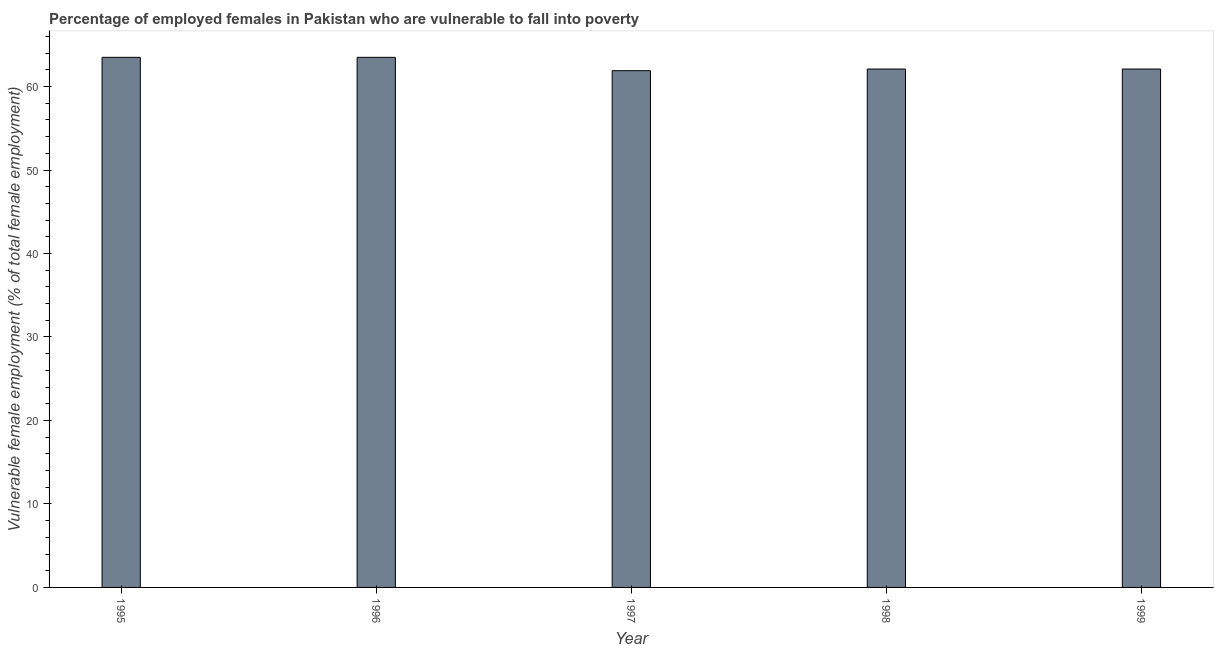Does the graph contain any zero values?
Provide a succinct answer. No. Does the graph contain grids?
Offer a terse response. No. What is the title of the graph?
Your response must be concise. Percentage of employed females in Pakistan who are vulnerable to fall into poverty. What is the label or title of the X-axis?
Provide a succinct answer. Year. What is the label or title of the Y-axis?
Ensure brevity in your answer.  Vulnerable female employment (% of total female employment). What is the percentage of employed females who are vulnerable to fall into poverty in 1999?
Your answer should be very brief. 62.1. Across all years, what is the maximum percentage of employed females who are vulnerable to fall into poverty?
Provide a short and direct response. 63.5. Across all years, what is the minimum percentage of employed females who are vulnerable to fall into poverty?
Provide a short and direct response. 61.9. What is the sum of the percentage of employed females who are vulnerable to fall into poverty?
Provide a short and direct response. 313.1. What is the difference between the percentage of employed females who are vulnerable to fall into poverty in 1995 and 1998?
Provide a succinct answer. 1.4. What is the average percentage of employed females who are vulnerable to fall into poverty per year?
Provide a short and direct response. 62.62. What is the median percentage of employed females who are vulnerable to fall into poverty?
Keep it short and to the point. 62.1. Is the percentage of employed females who are vulnerable to fall into poverty in 1996 less than that in 1997?
Offer a very short reply. No. What is the difference between the highest and the lowest percentage of employed females who are vulnerable to fall into poverty?
Ensure brevity in your answer.  1.6. How many bars are there?
Ensure brevity in your answer.  5. How many years are there in the graph?
Your answer should be compact. 5. What is the difference between two consecutive major ticks on the Y-axis?
Ensure brevity in your answer.  10. Are the values on the major ticks of Y-axis written in scientific E-notation?
Your response must be concise. No. What is the Vulnerable female employment (% of total female employment) in 1995?
Offer a very short reply. 63.5. What is the Vulnerable female employment (% of total female employment) of 1996?
Offer a very short reply. 63.5. What is the Vulnerable female employment (% of total female employment) in 1997?
Provide a short and direct response. 61.9. What is the Vulnerable female employment (% of total female employment) in 1998?
Offer a very short reply. 62.1. What is the Vulnerable female employment (% of total female employment) of 1999?
Give a very brief answer. 62.1. What is the difference between the Vulnerable female employment (% of total female employment) in 1995 and 1998?
Your response must be concise. 1.4. What is the difference between the Vulnerable female employment (% of total female employment) in 1996 and 1997?
Your answer should be compact. 1.6. What is the difference between the Vulnerable female employment (% of total female employment) in 1996 and 1998?
Offer a terse response. 1.4. What is the ratio of the Vulnerable female employment (% of total female employment) in 1995 to that in 1996?
Provide a succinct answer. 1. What is the ratio of the Vulnerable female employment (% of total female employment) in 1995 to that in 1999?
Provide a succinct answer. 1.02. What is the ratio of the Vulnerable female employment (% of total female employment) in 1996 to that in 1998?
Make the answer very short. 1.02. What is the ratio of the Vulnerable female employment (% of total female employment) in 1996 to that in 1999?
Provide a succinct answer. 1.02. What is the ratio of the Vulnerable female employment (% of total female employment) in 1997 to that in 1998?
Your answer should be compact. 1. What is the ratio of the Vulnerable female employment (% of total female employment) in 1998 to that in 1999?
Offer a terse response. 1. 